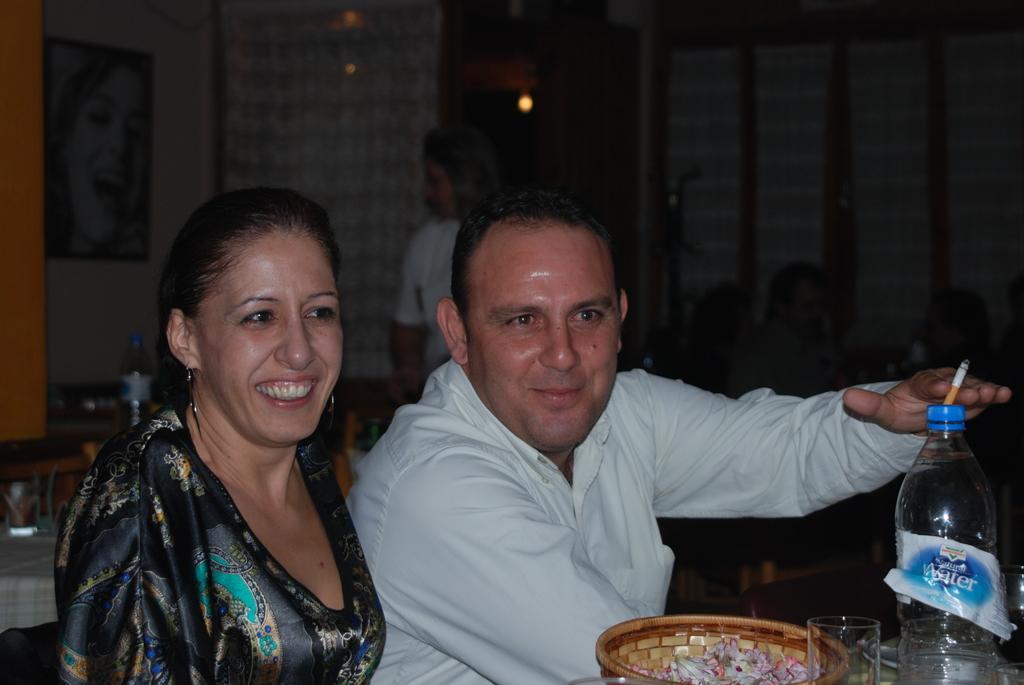Please provide a concise description of this image. There are two members sitting in the chairs in front of a table on which a water bottle, glass and a bowl was placed. There is a man and a woman in this picture. Both of them were smiling. In the background there is a woman standing. We can observe some photo frame attached to the wall and a curtain here. 